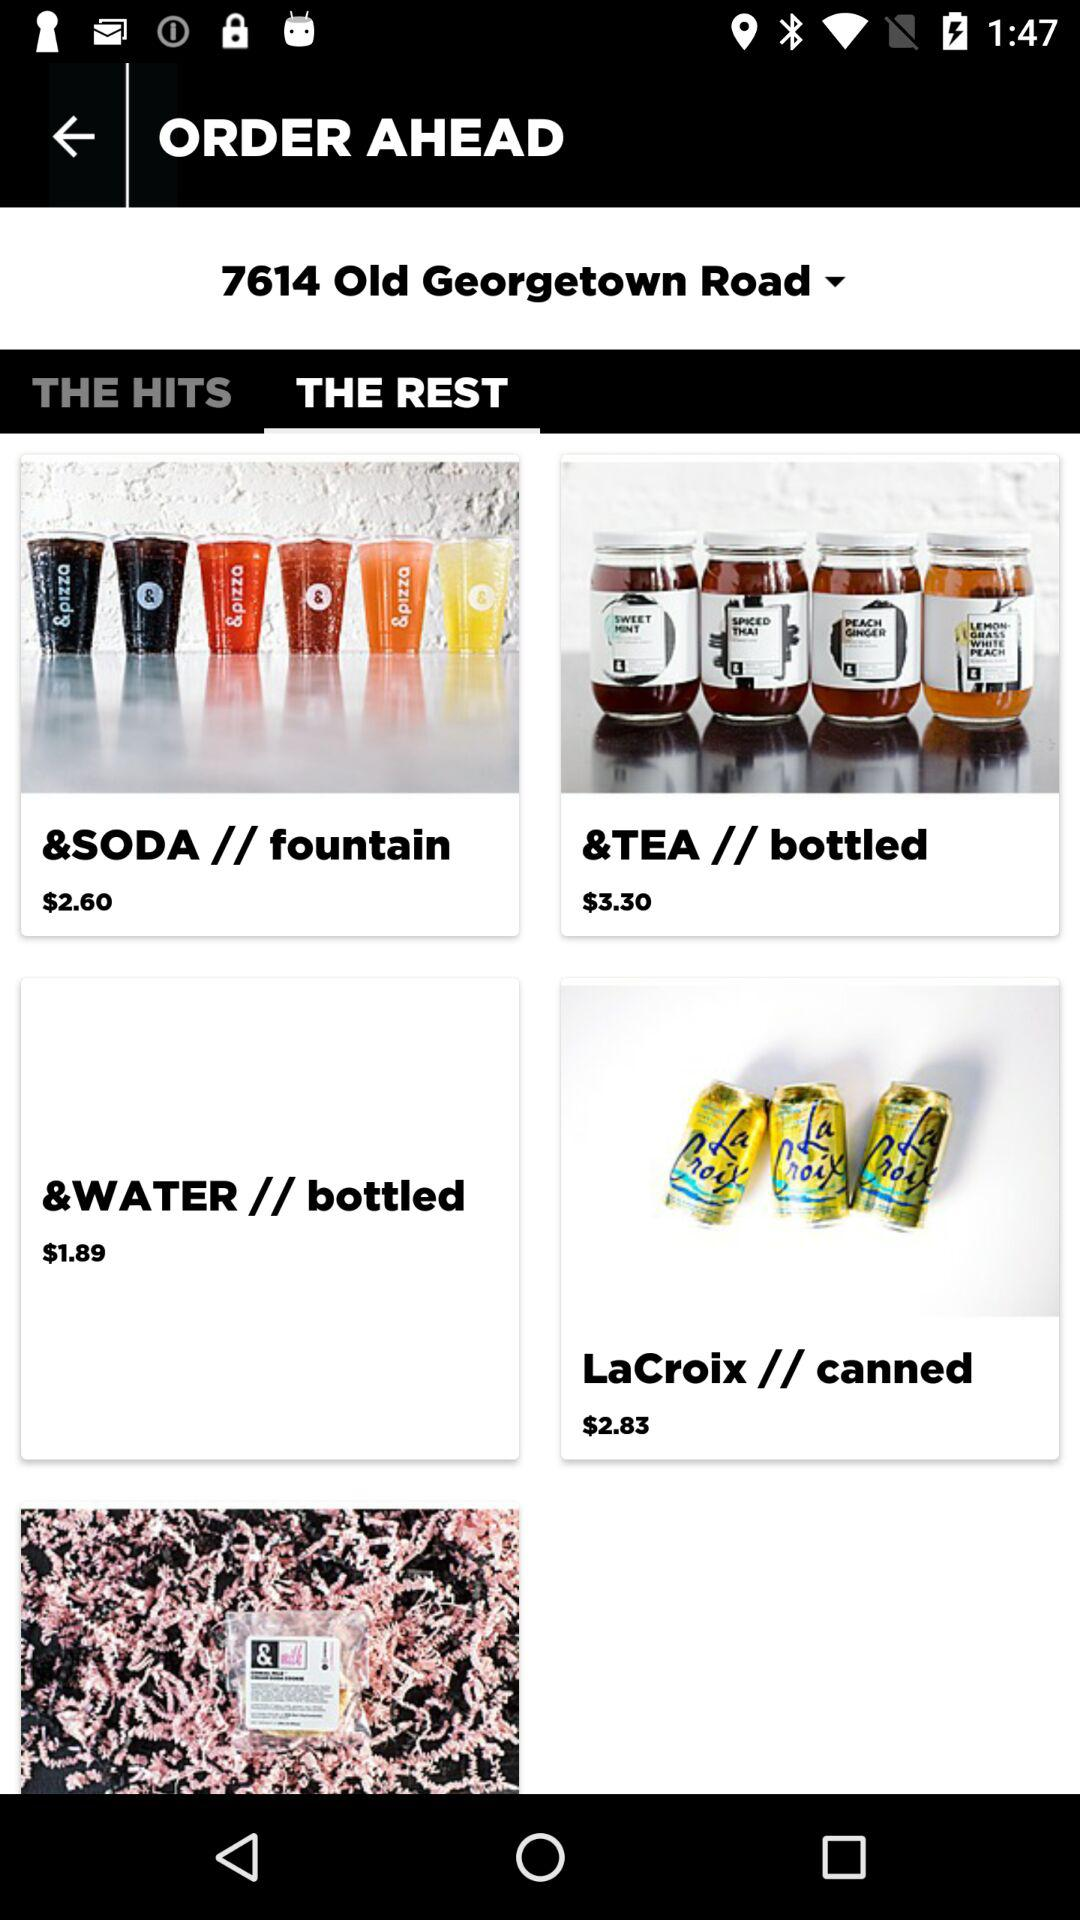How much more does the &WATER // bottled item cost than the &SODA // fountain item?
Answer the question using a single word or phrase. $0.71 